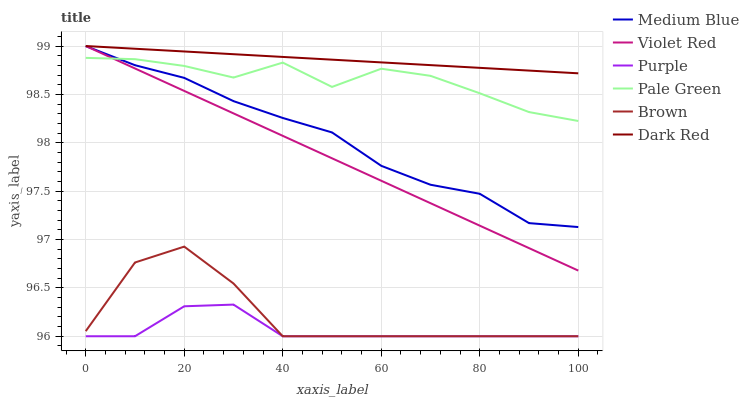Does Violet Red have the minimum area under the curve?
Answer yes or no. No. Does Violet Red have the maximum area under the curve?
Answer yes or no. No. Is Violet Red the smoothest?
Answer yes or no. No. Is Violet Red the roughest?
Answer yes or no. No. Does Violet Red have the lowest value?
Answer yes or no. No. Does Purple have the highest value?
Answer yes or no. No. Is Purple less than Medium Blue?
Answer yes or no. Yes. Is Violet Red greater than Brown?
Answer yes or no. Yes. Does Purple intersect Medium Blue?
Answer yes or no. No. 